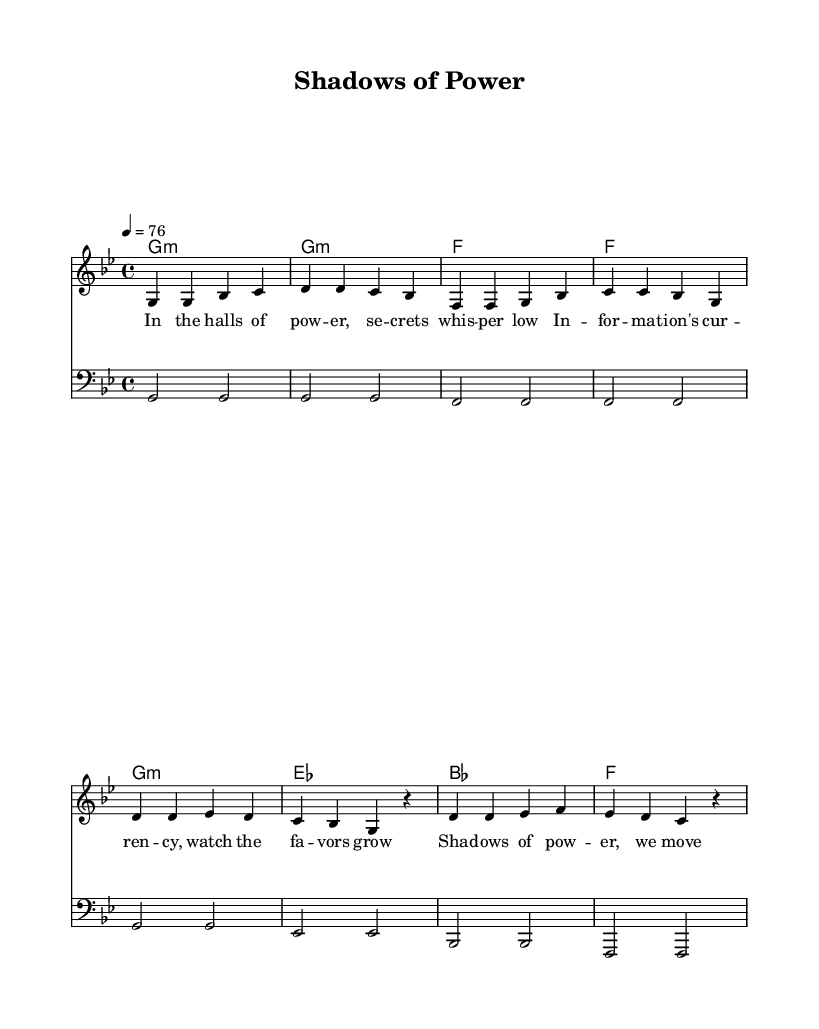What is the key signature of this music? The key signature indicates the scale on which the music is based. In the provided music, the key is G minor, which has two flats in its signature (B♭ and E♭), as can be seen at the beginning of the staff.
Answer: G minor What is the time signature of this music? The time signature shows the number of beats in each measure and which note value gets one beat. The time signature in the music is 4/4, meaning there are four beats per measure and the quarter note receives one beat, which is indicated right after the key signature.
Answer: 4/4 What is the tempo marking for this piece? The tempo marking indicates the speed at which the music should be played. In this music, the tempo is marked as quarter note equals 76 beats per minute, noted at the beginning of the score in the tempo line.
Answer: 76 How many measures are in the verse section? To find the number of measures in the verse, count the distinct bars present in the verse section of the sheet music. In this case, there are 4 measures, as segmenting the verse lyrics shows 4 distinct bars.
Answer: 4 What is the primary theme explored in the lyrics of this song? The lyrics talk about power, influence, and secrecy, which are conveyed through the phrases describing whispers of secrets and pulling strings behind the scenes. This central theme of manipulation and hidden control is usual in reggae music reflecting social and political issues.
Answer: Power and secrecy Which chords are used in the chorus? Looking at the chord section associated with the chorus, the specific chords played during the chorus are G minor, E♭ major, B♭ major, and F major. These can be identified by examining the chord changes laid out under the chorus section.
Answer: G minor, E flat, B flat, F major What style does this reggae song reflect based on its lyrics and music? By analyzing both the lyrical content focusing on themes like secrecy and the traditional reggae rhythms and chord progressions, one can determine that this song reflects a roots reggae style, often characterized by its socially conscious lyrics and laid-back groove.
Answer: Roots reggae 